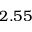Convert formula to latex. <formula><loc_0><loc_0><loc_500><loc_500>2 . 5 5</formula> 